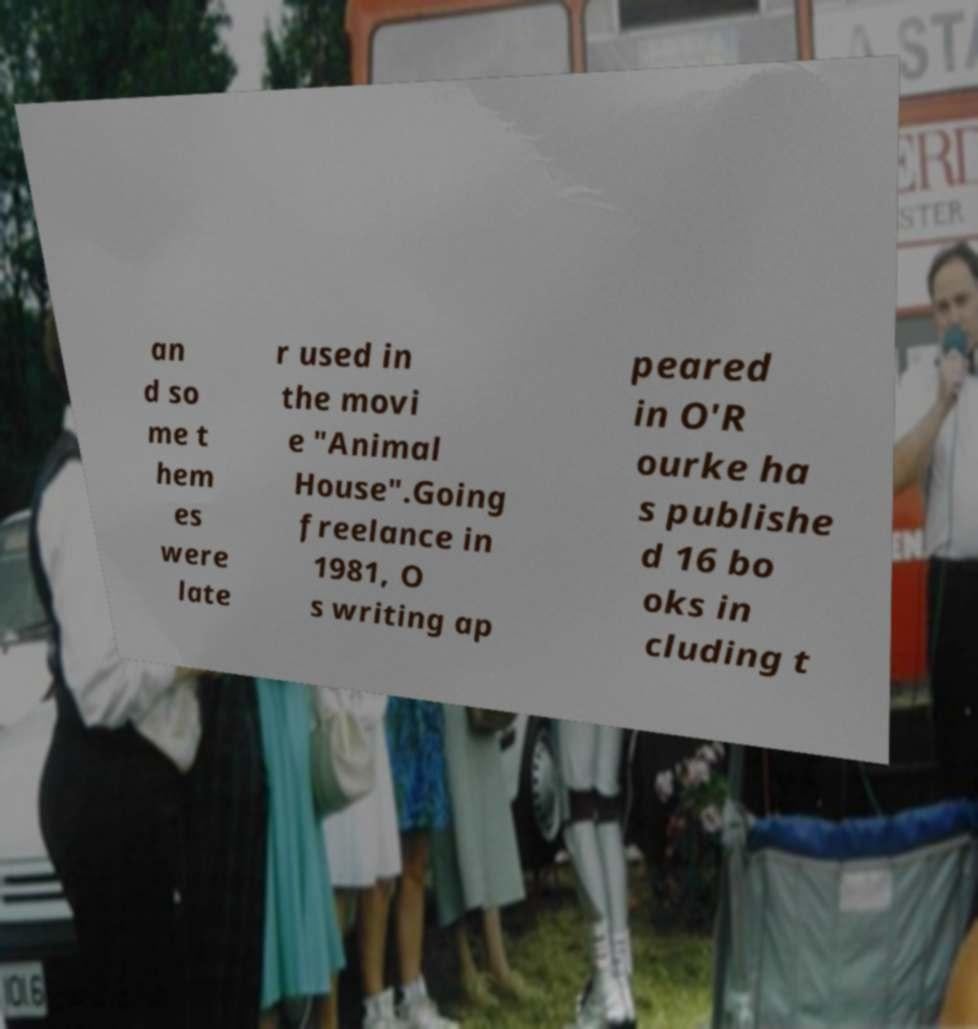I need the written content from this picture converted into text. Can you do that? an d so me t hem es were late r used in the movi e "Animal House".Going freelance in 1981, O s writing ap peared in O'R ourke ha s publishe d 16 bo oks in cluding t 